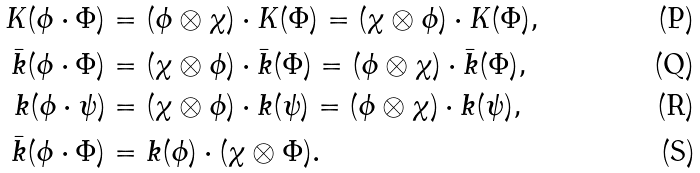Convert formula to latex. <formula><loc_0><loc_0><loc_500><loc_500>K ( \phi \cdot \Phi ) & = ( \phi \otimes \chi ) \cdot K ( \Phi ) = ( \chi \otimes \phi ) \cdot K ( \Phi ) , \\ \bar { k } ( \phi \cdot \Phi ) & = ( \chi \otimes \phi ) \cdot \bar { k } ( \Phi ) = ( \phi \otimes \chi ) \cdot \bar { k } ( \Phi ) , \\ k ( \phi \cdot \psi ) & = ( \chi \otimes \phi ) \cdot k ( \psi ) = ( \phi \otimes \chi ) \cdot k ( \psi ) , \\ \bar { k } ( \phi \cdot \Phi ) & = k ( \phi ) \cdot ( \chi \otimes \Phi ) .</formula> 